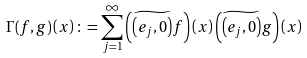Convert formula to latex. <formula><loc_0><loc_0><loc_500><loc_500>\Gamma ( f , g ) \left ( x \right ) \colon = \sum _ { j = 1 } ^ { \infty } \left ( \widetilde { \left ( e _ { j } , 0 \right ) } f \right ) \left ( x \right ) \left ( \widetilde { \left ( e _ { j } , 0 \right ) } g \right ) \left ( x \right )</formula> 